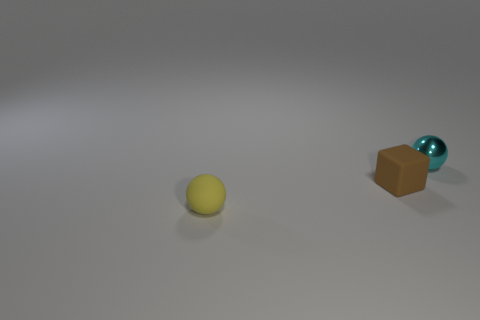Add 2 small brown rubber objects. How many objects exist? 5 Subtract all blocks. How many objects are left? 2 Subtract 1 cubes. How many cubes are left? 0 Add 3 tiny yellow spheres. How many tiny yellow spheres exist? 4 Subtract all yellow spheres. How many spheres are left? 1 Subtract 0 green spheres. How many objects are left? 3 Subtract all blue blocks. Subtract all red balls. How many blocks are left? 1 Subtract all red spheres. How many purple blocks are left? 0 Subtract all brown rubber spheres. Subtract all tiny cyan metal things. How many objects are left? 2 Add 3 balls. How many balls are left? 5 